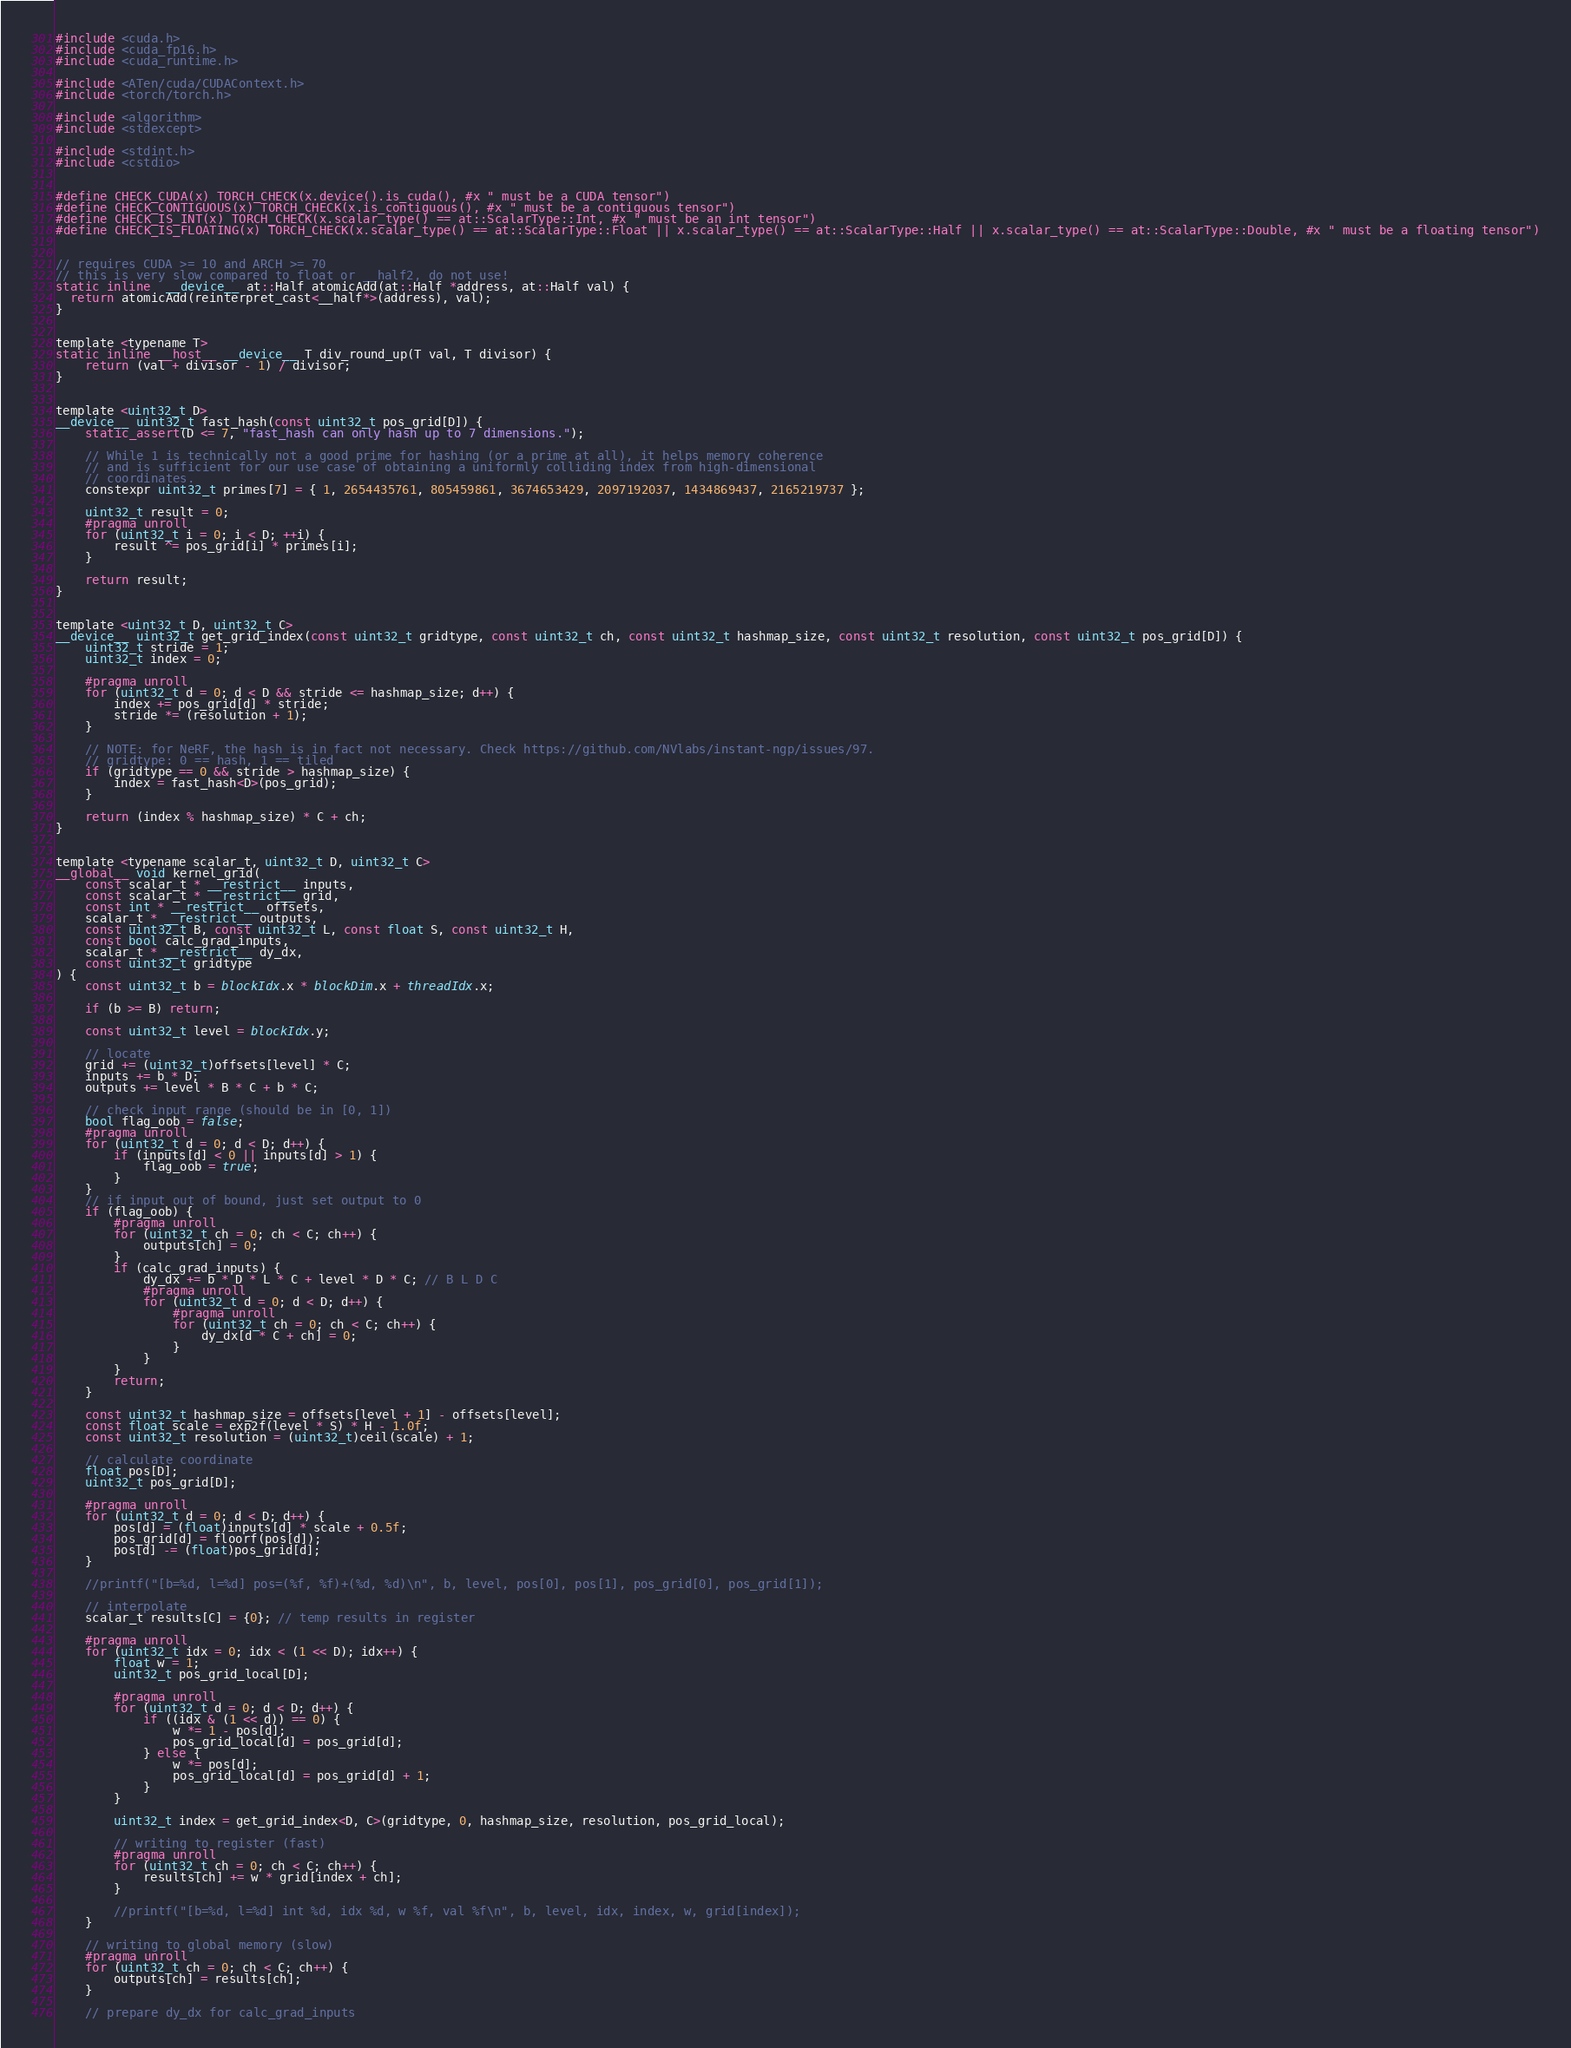<code> <loc_0><loc_0><loc_500><loc_500><_Cuda_>#include <cuda.h>
#include <cuda_fp16.h>
#include <cuda_runtime.h>

#include <ATen/cuda/CUDAContext.h>
#include <torch/torch.h>

#include <algorithm>
#include <stdexcept>

#include <stdint.h>
#include <cstdio>


#define CHECK_CUDA(x) TORCH_CHECK(x.device().is_cuda(), #x " must be a CUDA tensor")
#define CHECK_CONTIGUOUS(x) TORCH_CHECK(x.is_contiguous(), #x " must be a contiguous tensor")
#define CHECK_IS_INT(x) TORCH_CHECK(x.scalar_type() == at::ScalarType::Int, #x " must be an int tensor")
#define CHECK_IS_FLOATING(x) TORCH_CHECK(x.scalar_type() == at::ScalarType::Float || x.scalar_type() == at::ScalarType::Half || x.scalar_type() == at::ScalarType::Double, #x " must be a floating tensor")


// requires CUDA >= 10 and ARCH >= 70
// this is very slow compared to float or __half2, do not use!
static inline  __device__ at::Half atomicAdd(at::Half *address, at::Half val) {
  return atomicAdd(reinterpret_cast<__half*>(address), val);
}


template <typename T>
static inline __host__ __device__ T div_round_up(T val, T divisor) {
    return (val + divisor - 1) / divisor;
}


template <uint32_t D>
__device__ uint32_t fast_hash(const uint32_t pos_grid[D]) {
    static_assert(D <= 7, "fast_hash can only hash up to 7 dimensions.");

    // While 1 is technically not a good prime for hashing (or a prime at all), it helps memory coherence
    // and is sufficient for our use case of obtaining a uniformly colliding index from high-dimensional
    // coordinates.
    constexpr uint32_t primes[7] = { 1, 2654435761, 805459861, 3674653429, 2097192037, 1434869437, 2165219737 };

    uint32_t result = 0;
    #pragma unroll
    for (uint32_t i = 0; i < D; ++i) {
        result ^= pos_grid[i] * primes[i];
    }

    return result;
}


template <uint32_t D, uint32_t C>
__device__ uint32_t get_grid_index(const uint32_t gridtype, const uint32_t ch, const uint32_t hashmap_size, const uint32_t resolution, const uint32_t pos_grid[D]) {
    uint32_t stride = 1;
    uint32_t index = 0;

    #pragma unroll
    for (uint32_t d = 0; d < D && stride <= hashmap_size; d++) {
        index += pos_grid[d] * stride;
        stride *= (resolution + 1);
    }

    // NOTE: for NeRF, the hash is in fact not necessary. Check https://github.com/NVlabs/instant-ngp/issues/97.
    // gridtype: 0 == hash, 1 == tiled
    if (gridtype == 0 && stride > hashmap_size) {
        index = fast_hash<D>(pos_grid);
    }

    return (index % hashmap_size) * C + ch;
}


template <typename scalar_t, uint32_t D, uint32_t C>
__global__ void kernel_grid(
    const scalar_t * __restrict__ inputs, 
    const scalar_t * __restrict__ grid, 
    const int * __restrict__ offsets, 
    scalar_t * __restrict__ outputs, 
    const uint32_t B, const uint32_t L, const float S, const uint32_t H,
    const bool calc_grad_inputs, 
    scalar_t * __restrict__ dy_dx,
    const uint32_t gridtype
) {
    const uint32_t b = blockIdx.x * blockDim.x + threadIdx.x;
    
    if (b >= B) return;

    const uint32_t level = blockIdx.y;
    
    // locate
    grid += (uint32_t)offsets[level] * C;
    inputs += b * D;
    outputs += level * B * C + b * C;

    // check input range (should be in [0, 1])
    bool flag_oob = false;
    #pragma unroll
    for (uint32_t d = 0; d < D; d++) {
        if (inputs[d] < 0 || inputs[d] > 1) {
            flag_oob = true;
        }
    }
    // if input out of bound, just set output to 0
    if (flag_oob) {
        #pragma unroll
        for (uint32_t ch = 0; ch < C; ch++) {
            outputs[ch] = 0; 
        }
        if (calc_grad_inputs) {
            dy_dx += b * D * L * C + level * D * C; // B L D C
            #pragma unroll
            for (uint32_t d = 0; d < D; d++) {
                #pragma unroll
                for (uint32_t ch = 0; ch < C; ch++) {
                    dy_dx[d * C + ch] = 0; 
                }       
            }
        }
        return;
    }

    const uint32_t hashmap_size = offsets[level + 1] - offsets[level];
    const float scale = exp2f(level * S) * H - 1.0f;
    const uint32_t resolution = (uint32_t)ceil(scale) + 1;
    
    // calculate coordinate
    float pos[D];
    uint32_t pos_grid[D];

    #pragma unroll
    for (uint32_t d = 0; d < D; d++) {
        pos[d] = (float)inputs[d] * scale + 0.5f;
        pos_grid[d] = floorf(pos[d]);
        pos[d] -= (float)pos_grid[d];
    }

    //printf("[b=%d, l=%d] pos=(%f, %f)+(%d, %d)\n", b, level, pos[0], pos[1], pos_grid[0], pos_grid[1]);

    // interpolate
    scalar_t results[C] = {0}; // temp results in register

    #pragma unroll
    for (uint32_t idx = 0; idx < (1 << D); idx++) {
        float w = 1;
        uint32_t pos_grid_local[D];

        #pragma unroll
        for (uint32_t d = 0; d < D; d++) {
            if ((idx & (1 << d)) == 0) {
                w *= 1 - pos[d];
                pos_grid_local[d] = pos_grid[d];
            } else {
                w *= pos[d];
                pos_grid_local[d] = pos_grid[d] + 1;
            }
        }

        uint32_t index = get_grid_index<D, C>(gridtype, 0, hashmap_size, resolution, pos_grid_local);

        // writing to register (fast)
        #pragma unroll
        for (uint32_t ch = 0; ch < C; ch++) {
            results[ch] += w * grid[index + ch];
        }

        //printf("[b=%d, l=%d] int %d, idx %d, w %f, val %f\n", b, level, idx, index, w, grid[index]);
    }    

    // writing to global memory (slow)
    #pragma unroll
    for (uint32_t ch = 0; ch < C; ch++) {
        outputs[ch] = results[ch]; 
    }

    // prepare dy_dx for calc_grad_inputs</code> 